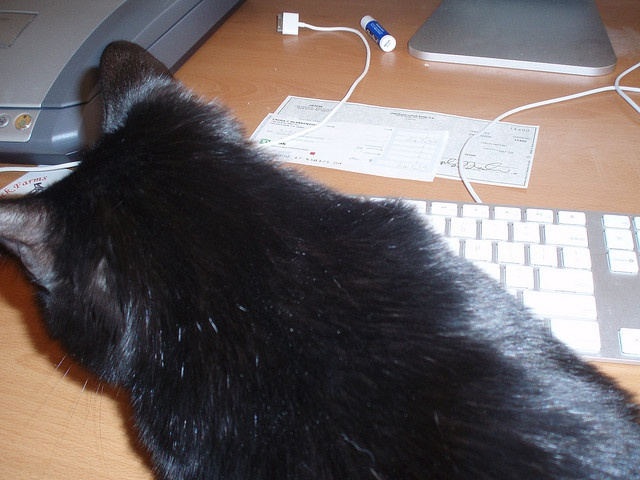Describe the objects in this image and their specific colors. I can see cat in black, gray, and darkgray tones and keyboard in black, white, darkgray, and lightgray tones in this image. 